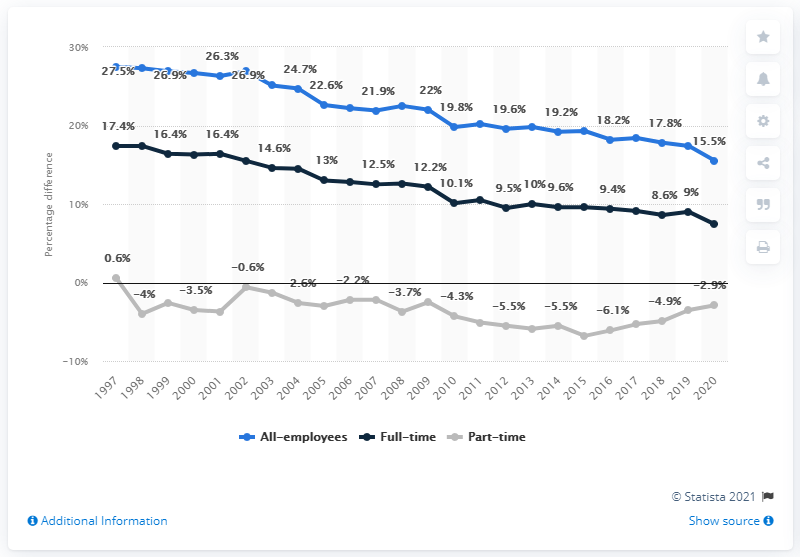Specify some key components in this picture. In 1997, the gender pay gap was at its highest level. In 2020, the average hourly earnings for full-time workers in the UK was 7.4. In 2020, the difference between the average hourly earnings for men and women in the UK was 15.5%. 